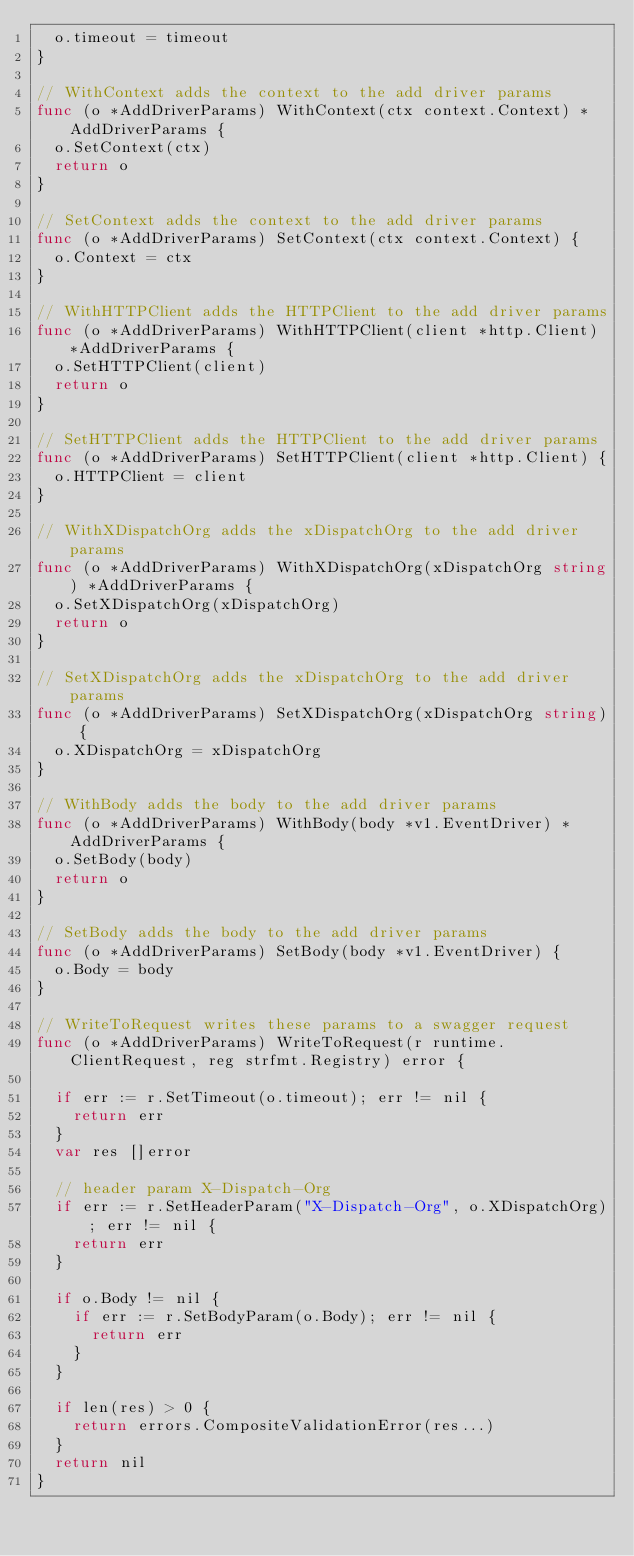Convert code to text. <code><loc_0><loc_0><loc_500><loc_500><_Go_>	o.timeout = timeout
}

// WithContext adds the context to the add driver params
func (o *AddDriverParams) WithContext(ctx context.Context) *AddDriverParams {
	o.SetContext(ctx)
	return o
}

// SetContext adds the context to the add driver params
func (o *AddDriverParams) SetContext(ctx context.Context) {
	o.Context = ctx
}

// WithHTTPClient adds the HTTPClient to the add driver params
func (o *AddDriverParams) WithHTTPClient(client *http.Client) *AddDriverParams {
	o.SetHTTPClient(client)
	return o
}

// SetHTTPClient adds the HTTPClient to the add driver params
func (o *AddDriverParams) SetHTTPClient(client *http.Client) {
	o.HTTPClient = client
}

// WithXDispatchOrg adds the xDispatchOrg to the add driver params
func (o *AddDriverParams) WithXDispatchOrg(xDispatchOrg string) *AddDriverParams {
	o.SetXDispatchOrg(xDispatchOrg)
	return o
}

// SetXDispatchOrg adds the xDispatchOrg to the add driver params
func (o *AddDriverParams) SetXDispatchOrg(xDispatchOrg string) {
	o.XDispatchOrg = xDispatchOrg
}

// WithBody adds the body to the add driver params
func (o *AddDriverParams) WithBody(body *v1.EventDriver) *AddDriverParams {
	o.SetBody(body)
	return o
}

// SetBody adds the body to the add driver params
func (o *AddDriverParams) SetBody(body *v1.EventDriver) {
	o.Body = body
}

// WriteToRequest writes these params to a swagger request
func (o *AddDriverParams) WriteToRequest(r runtime.ClientRequest, reg strfmt.Registry) error {

	if err := r.SetTimeout(o.timeout); err != nil {
		return err
	}
	var res []error

	// header param X-Dispatch-Org
	if err := r.SetHeaderParam("X-Dispatch-Org", o.XDispatchOrg); err != nil {
		return err
	}

	if o.Body != nil {
		if err := r.SetBodyParam(o.Body); err != nil {
			return err
		}
	}

	if len(res) > 0 {
		return errors.CompositeValidationError(res...)
	}
	return nil
}
</code> 